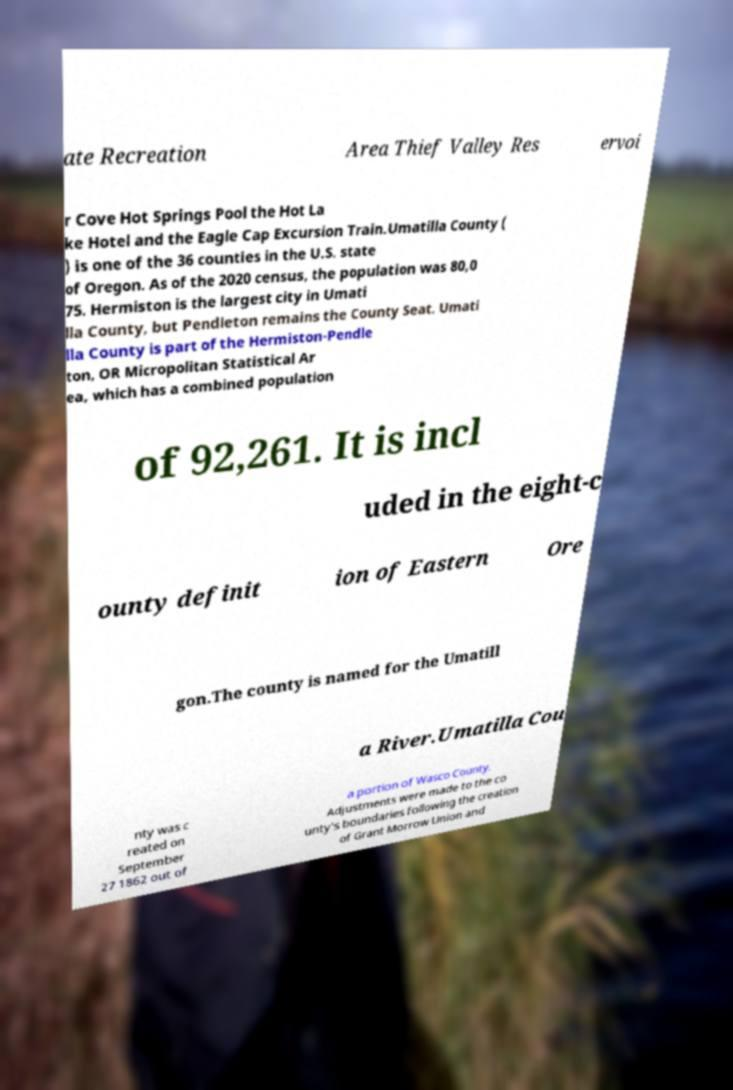There's text embedded in this image that I need extracted. Can you transcribe it verbatim? ate Recreation Area Thief Valley Res ervoi r Cove Hot Springs Pool the Hot La ke Hotel and the Eagle Cap Excursion Train.Umatilla County ( ) is one of the 36 counties in the U.S. state of Oregon. As of the 2020 census, the population was 80,0 75. Hermiston is the largest city in Umati lla County, but Pendleton remains the County Seat. Umati lla County is part of the Hermiston-Pendle ton, OR Micropolitan Statistical Ar ea, which has a combined population of 92,261. It is incl uded in the eight-c ounty definit ion of Eastern Ore gon.The county is named for the Umatill a River.Umatilla Cou nty was c reated on September 27 1862 out of a portion of Wasco County. Adjustments were made to the co unty's boundaries following the creation of Grant Morrow Union and 